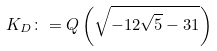Convert formula to latex. <formula><loc_0><loc_0><loc_500><loc_500>K _ { D } \colon = Q \left ( \sqrt { - 1 2 \sqrt { 5 } - 3 1 } \right )</formula> 